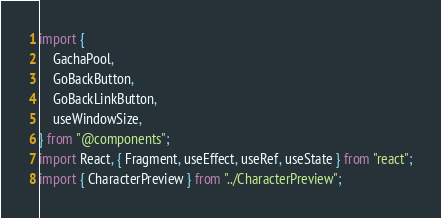<code> <loc_0><loc_0><loc_500><loc_500><_TypeScript_>import {
    GachaPool,
    GoBackButton,
    GoBackLinkButton,
    useWindowSize,
} from "@components";
import React, { Fragment, useEffect, useRef, useState } from "react";
import { CharacterPreview } from "../CharacterPreview";</code> 